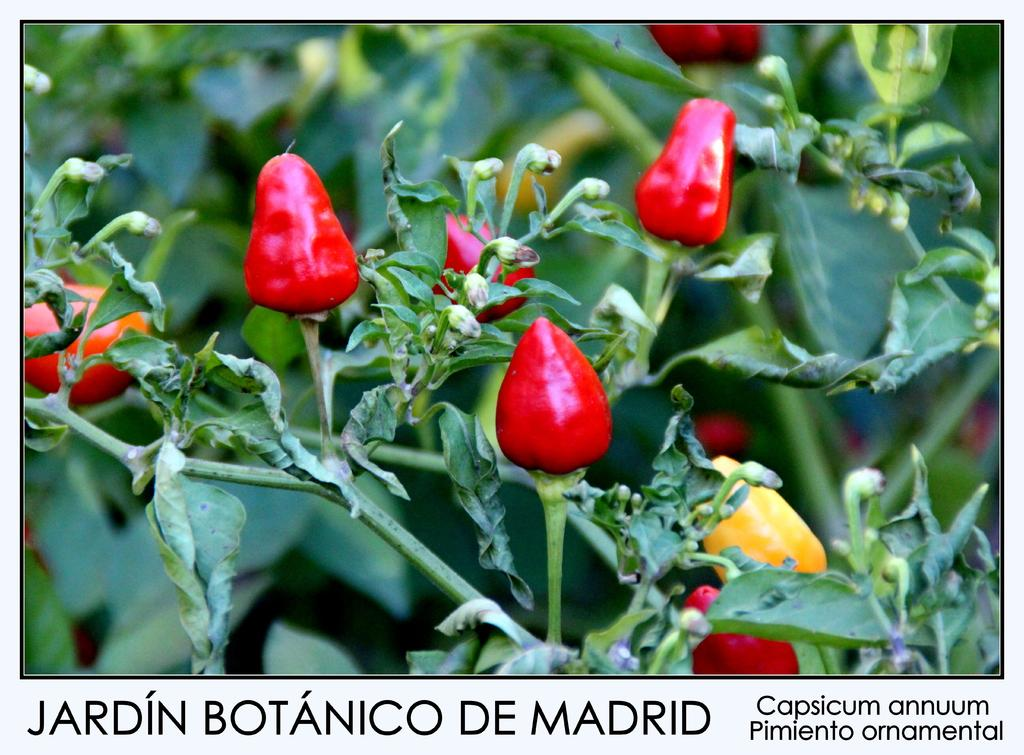What color are the capsicums on the plants in the image? There are red and yellow capsicums on the plants in the image. Can you describe the plants in the image? The plants in the image have capsicums growing on them. What is located at the bottom of the image? There is text at the bottom of the image. What type of skirt can be seen in the image? There is no skirt present in the image; it features plants with red and yellow capsicums and text at the bottom. 